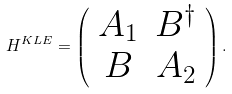Convert formula to latex. <formula><loc_0><loc_0><loc_500><loc_500>H ^ { K L E } = \left ( \begin{array} { c c } A _ { 1 } & B ^ { \dagger } \\ B & A _ { 2 } \end{array} \right ) .</formula> 